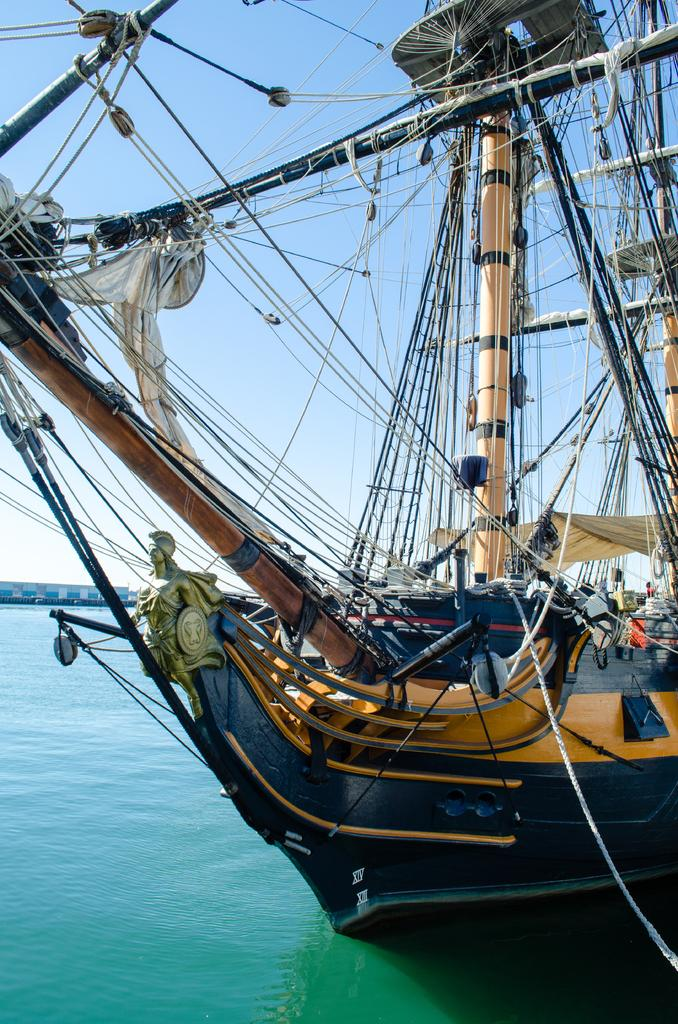What is at the bottom of the image? There is water at the bottom of the image. What is floating on the water? There is a ship on the water. What features can be seen on the ship? The ship has poles and ropes. What else is on the ship? There are clothes and a sculpture on the ship. What can be seen in the background of the image? The sky is visible in the background of the image. How many jellyfish are swimming around the ship in the image? There are no jellyfish present in the image. What type of rake is being used to clean the deck of the ship? There is no rake visible in the image. 